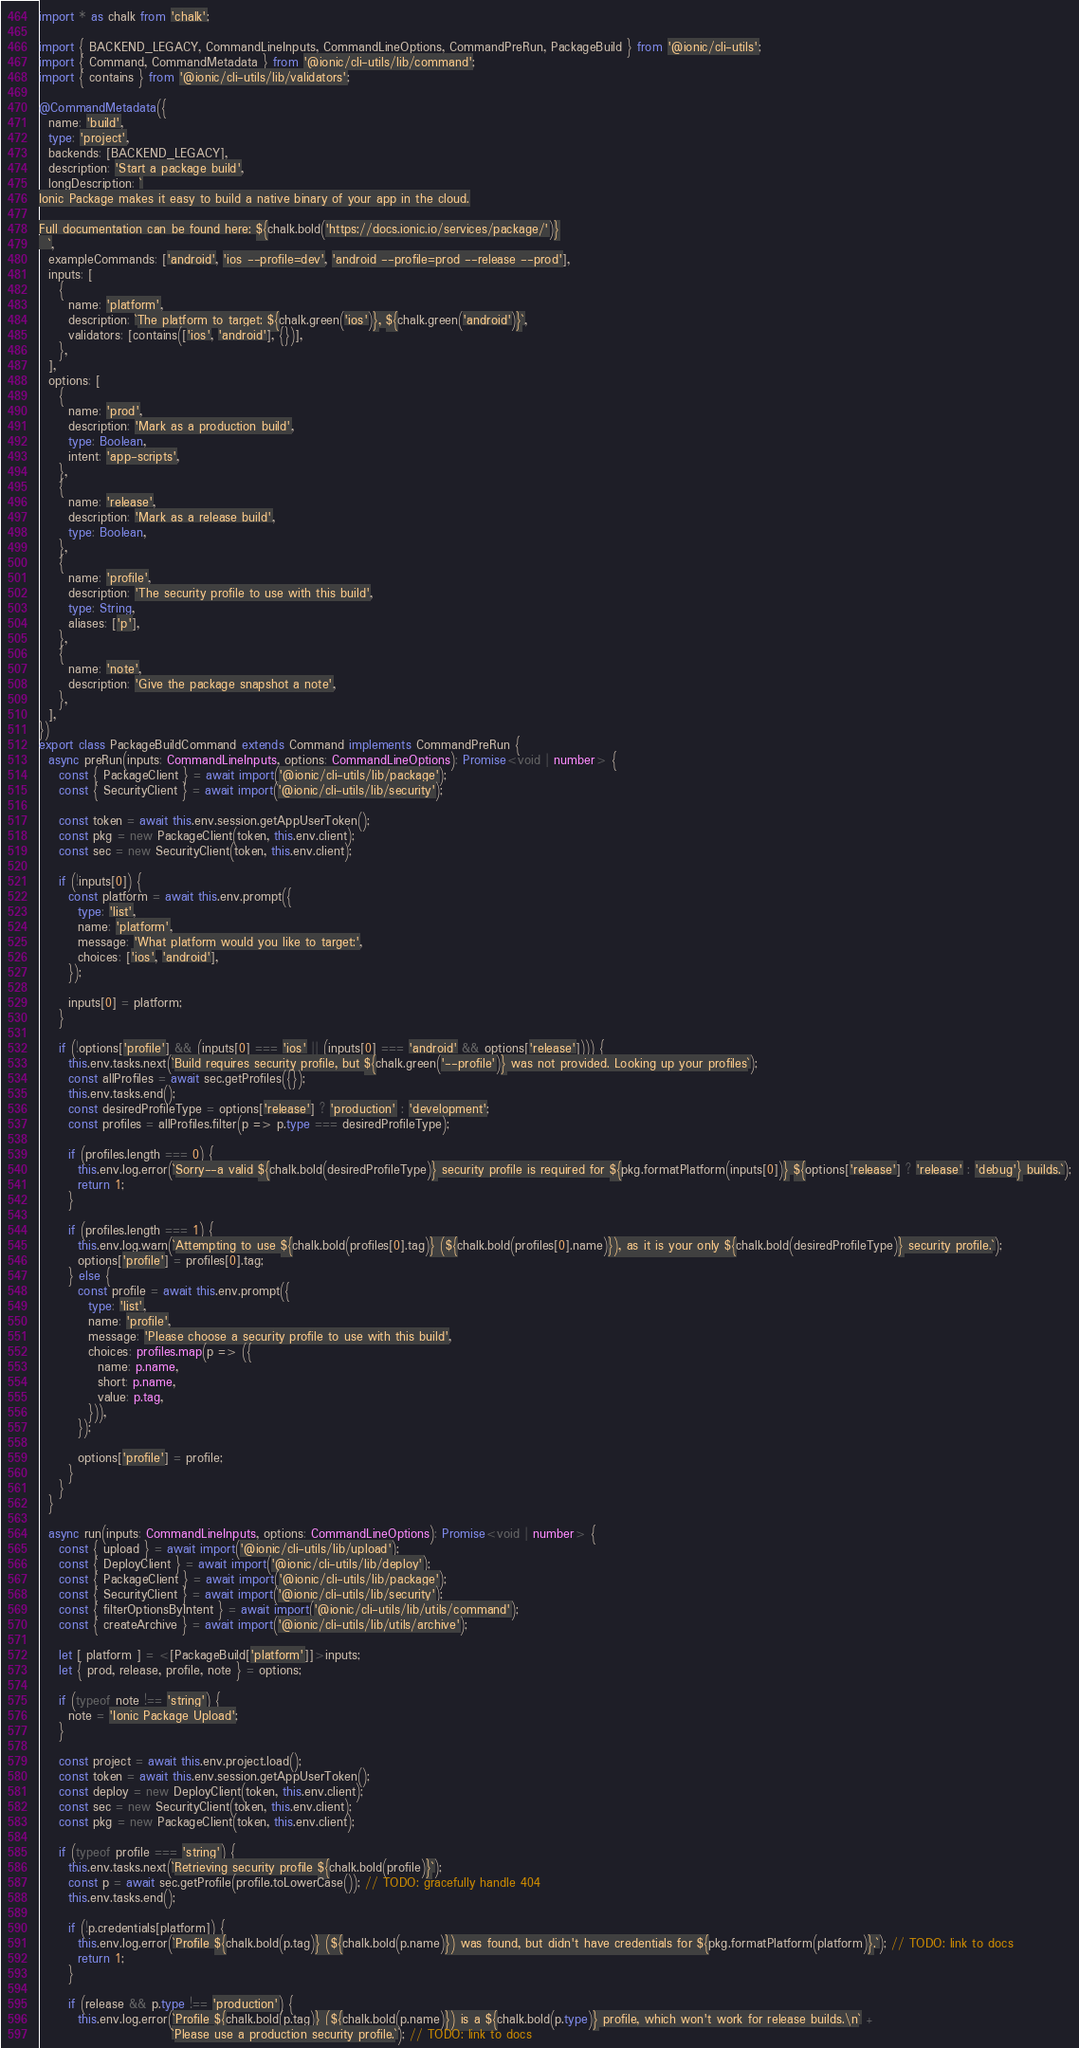<code> <loc_0><loc_0><loc_500><loc_500><_TypeScript_>import * as chalk from 'chalk';

import { BACKEND_LEGACY, CommandLineInputs, CommandLineOptions, CommandPreRun, PackageBuild } from '@ionic/cli-utils';
import { Command, CommandMetadata } from '@ionic/cli-utils/lib/command';
import { contains } from '@ionic/cli-utils/lib/validators';

@CommandMetadata({
  name: 'build',
  type: 'project',
  backends: [BACKEND_LEGACY],
  description: 'Start a package build',
  longDescription: `
Ionic Package makes it easy to build a native binary of your app in the cloud.

Full documentation can be found here: ${chalk.bold('https://docs.ionic.io/services/package/')}
  `,
  exampleCommands: ['android', 'ios --profile=dev', 'android --profile=prod --release --prod'],
  inputs: [
    {
      name: 'platform',
      description: `The platform to target: ${chalk.green('ios')}, ${chalk.green('android')}`,
      validators: [contains(['ios', 'android'], {})],
    },
  ],
  options: [
    {
      name: 'prod',
      description: 'Mark as a production build',
      type: Boolean,
      intent: 'app-scripts',
    },
    {
      name: 'release',
      description: 'Mark as a release build',
      type: Boolean,
    },
    {
      name: 'profile',
      description: 'The security profile to use with this build',
      type: String,
      aliases: ['p'],
    },
    {
      name: 'note',
      description: 'Give the package snapshot a note',
    },
  ],
})
export class PackageBuildCommand extends Command implements CommandPreRun {
  async preRun(inputs: CommandLineInputs, options: CommandLineOptions): Promise<void | number> {
    const { PackageClient } = await import('@ionic/cli-utils/lib/package');
    const { SecurityClient } = await import('@ionic/cli-utils/lib/security');

    const token = await this.env.session.getAppUserToken();
    const pkg = new PackageClient(token, this.env.client);
    const sec = new SecurityClient(token, this.env.client);

    if (!inputs[0]) {
      const platform = await this.env.prompt({
        type: 'list',
        name: 'platform',
        message: 'What platform would you like to target:',
        choices: ['ios', 'android'],
      });

      inputs[0] = platform;
    }

    if (!options['profile'] && (inputs[0] === 'ios' || (inputs[0] === 'android' && options['release']))) {
      this.env.tasks.next(`Build requires security profile, but ${chalk.green('--profile')} was not provided. Looking up your profiles`);
      const allProfiles = await sec.getProfiles({});
      this.env.tasks.end();
      const desiredProfileType = options['release'] ? 'production' : 'development';
      const profiles = allProfiles.filter(p => p.type === desiredProfileType);

      if (profiles.length === 0) {
        this.env.log.error(`Sorry--a valid ${chalk.bold(desiredProfileType)} security profile is required for ${pkg.formatPlatform(inputs[0])} ${options['release'] ? 'release' : 'debug'} builds.`);
        return 1;
      }

      if (profiles.length === 1) {
        this.env.log.warn(`Attempting to use ${chalk.bold(profiles[0].tag)} (${chalk.bold(profiles[0].name)}), as it is your only ${chalk.bold(desiredProfileType)} security profile.`);
        options['profile'] = profiles[0].tag;
      } else {
        const profile = await this.env.prompt({
          type: 'list',
          name: 'profile',
          message: 'Please choose a security profile to use with this build',
          choices: profiles.map(p => ({
            name: p.name,
            short: p.name,
            value: p.tag,
          })),
        });

        options['profile'] = profile;
      }
    }
  }

  async run(inputs: CommandLineInputs, options: CommandLineOptions): Promise<void | number> {
    const { upload } = await import('@ionic/cli-utils/lib/upload');
    const { DeployClient } = await import('@ionic/cli-utils/lib/deploy');
    const { PackageClient } = await import('@ionic/cli-utils/lib/package');
    const { SecurityClient } = await import('@ionic/cli-utils/lib/security');
    const { filterOptionsByIntent } = await import('@ionic/cli-utils/lib/utils/command');
    const { createArchive } = await import('@ionic/cli-utils/lib/utils/archive');

    let [ platform ] = <[PackageBuild['platform']]>inputs;
    let { prod, release, profile, note } = options;

    if (typeof note !== 'string') {
      note = 'Ionic Package Upload';
    }

    const project = await this.env.project.load();
    const token = await this.env.session.getAppUserToken();
    const deploy = new DeployClient(token, this.env.client);
    const sec = new SecurityClient(token, this.env.client);
    const pkg = new PackageClient(token, this.env.client);

    if (typeof profile === 'string') {
      this.env.tasks.next(`Retrieving security profile ${chalk.bold(profile)}`);
      const p = await sec.getProfile(profile.toLowerCase()); // TODO: gracefully handle 404
      this.env.tasks.end();

      if (!p.credentials[platform]) {
        this.env.log.error(`Profile ${chalk.bold(p.tag)} (${chalk.bold(p.name)}) was found, but didn't have credentials for ${pkg.formatPlatform(platform)}.`); // TODO: link to docs
        return 1;
      }

      if (release && p.type !== 'production') {
        this.env.log.error(`Profile ${chalk.bold(p.tag)} (${chalk.bold(p.name)}) is a ${chalk.bold(p.type)} profile, which won't work for release builds.\n` +
                           `Please use a production security profile.`); // TODO: link to docs</code> 